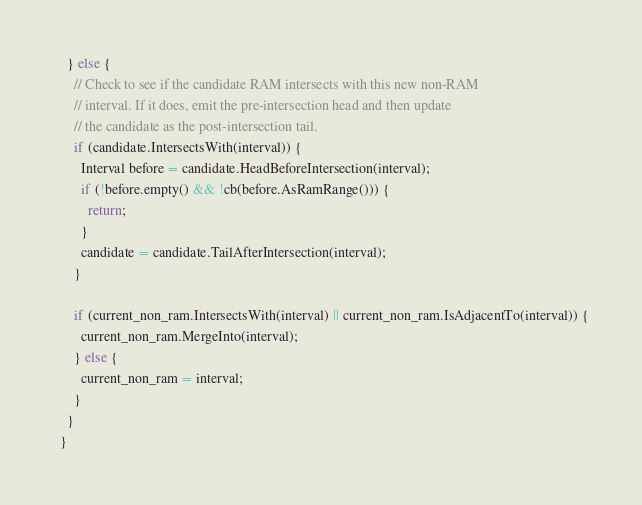<code> <loc_0><loc_0><loc_500><loc_500><_C++_>    } else {
      // Check to see if the candidate RAM intersects with this new non-RAM
      // interval. If it does, emit the pre-intersection head and then update
      // the candidate as the post-intersection tail.
      if (candidate.IntersectsWith(interval)) {
        Interval before = candidate.HeadBeforeIntersection(interval);
        if (!before.empty() && !cb(before.AsRamRange())) {
          return;
        }
        candidate = candidate.TailAfterIntersection(interval);
      }

      if (current_non_ram.IntersectsWith(interval) || current_non_ram.IsAdjacentTo(interval)) {
        current_non_ram.MergeInto(interval);
      } else {
        current_non_ram = interval;
      }
    }
  }
</code> 